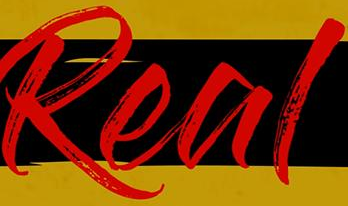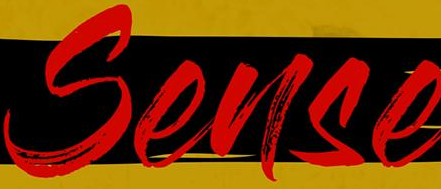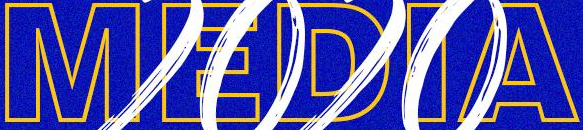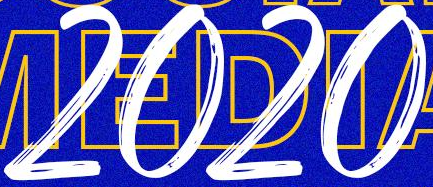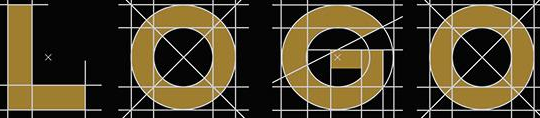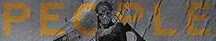Transcribe the words shown in these images in order, separated by a semicolon. Real; Sense; MEDIA; 2020; LOGO; PEOPLE 